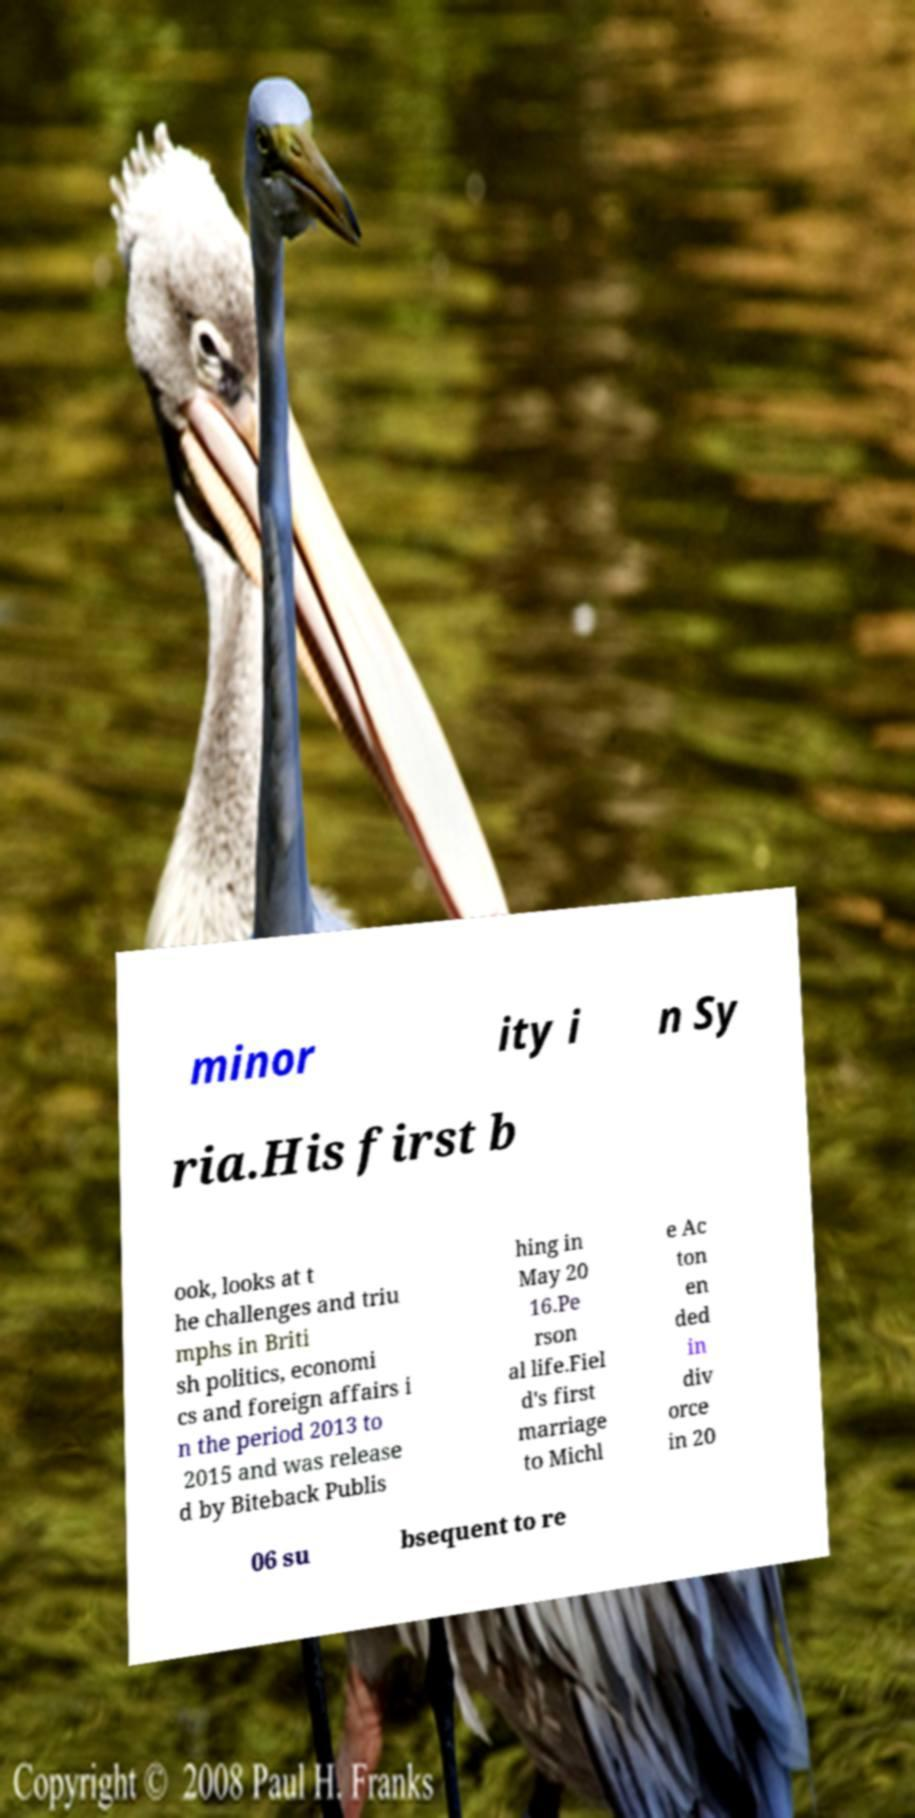There's text embedded in this image that I need extracted. Can you transcribe it verbatim? minor ity i n Sy ria.His first b ook, looks at t he challenges and triu mphs in Briti sh politics, economi cs and foreign affairs i n the period 2013 to 2015 and was release d by Biteback Publis hing in May 20 16.Pe rson al life.Fiel d's first marriage to Michl e Ac ton en ded in div orce in 20 06 su bsequent to re 